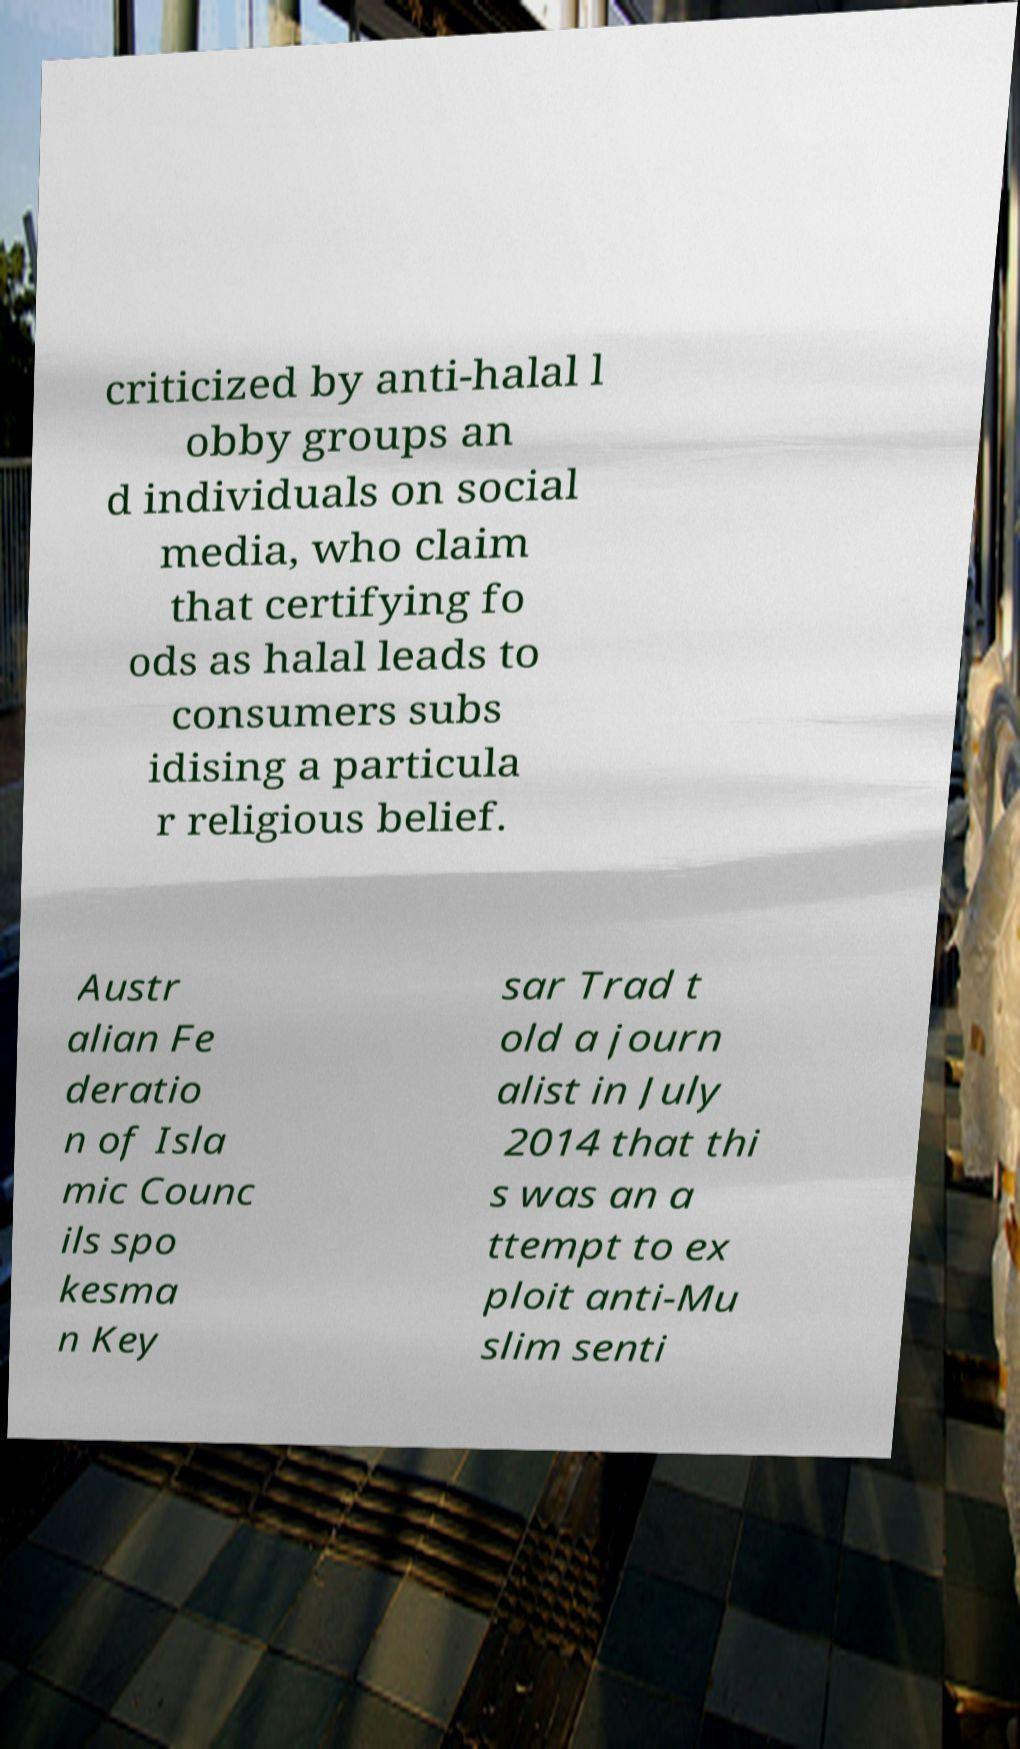Can you read and provide the text displayed in the image?This photo seems to have some interesting text. Can you extract and type it out for me? criticized by anti-halal l obby groups an d individuals on social media, who claim that certifying fo ods as halal leads to consumers subs idising a particula r religious belief. Austr alian Fe deratio n of Isla mic Counc ils spo kesma n Key sar Trad t old a journ alist in July 2014 that thi s was an a ttempt to ex ploit anti-Mu slim senti 